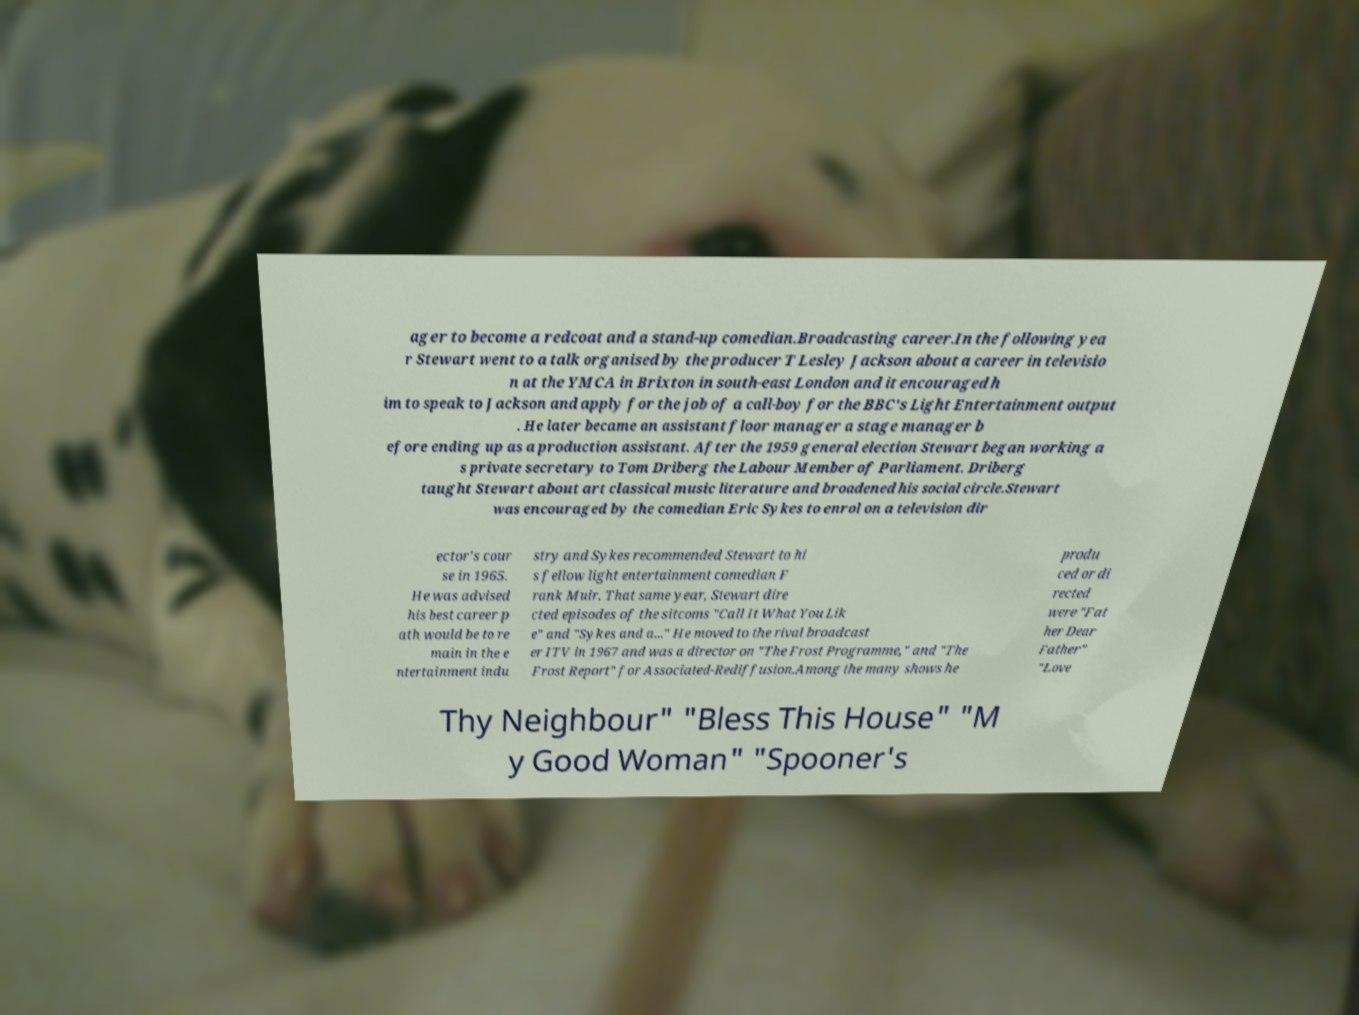Could you extract and type out the text from this image? ager to become a redcoat and a stand-up comedian.Broadcasting career.In the following yea r Stewart went to a talk organised by the producer T Lesley Jackson about a career in televisio n at the YMCA in Brixton in south-east London and it encouraged h im to speak to Jackson and apply for the job of a call-boy for the BBC's Light Entertainment output . He later became an assistant floor manager a stage manager b efore ending up as a production assistant. After the 1959 general election Stewart began working a s private secretary to Tom Driberg the Labour Member of Parliament. Driberg taught Stewart about art classical music literature and broadened his social circle.Stewart was encouraged by the comedian Eric Sykes to enrol on a television dir ector's cour se in 1965. He was advised his best career p ath would be to re main in the e ntertainment indu stry and Sykes recommended Stewart to hi s fellow light entertainment comedian F rank Muir. That same year, Stewart dire cted episodes of the sitcoms "Call It What You Lik e" and "Sykes and a..." He moved to the rival broadcast er ITV in 1967 and was a director on "The Frost Programme," and "The Frost Report" for Associated-Rediffusion.Among the many shows he produ ced or di rected were "Fat her Dear Father" "Love Thy Neighbour" "Bless This House" "M y Good Woman" "Spooner's 